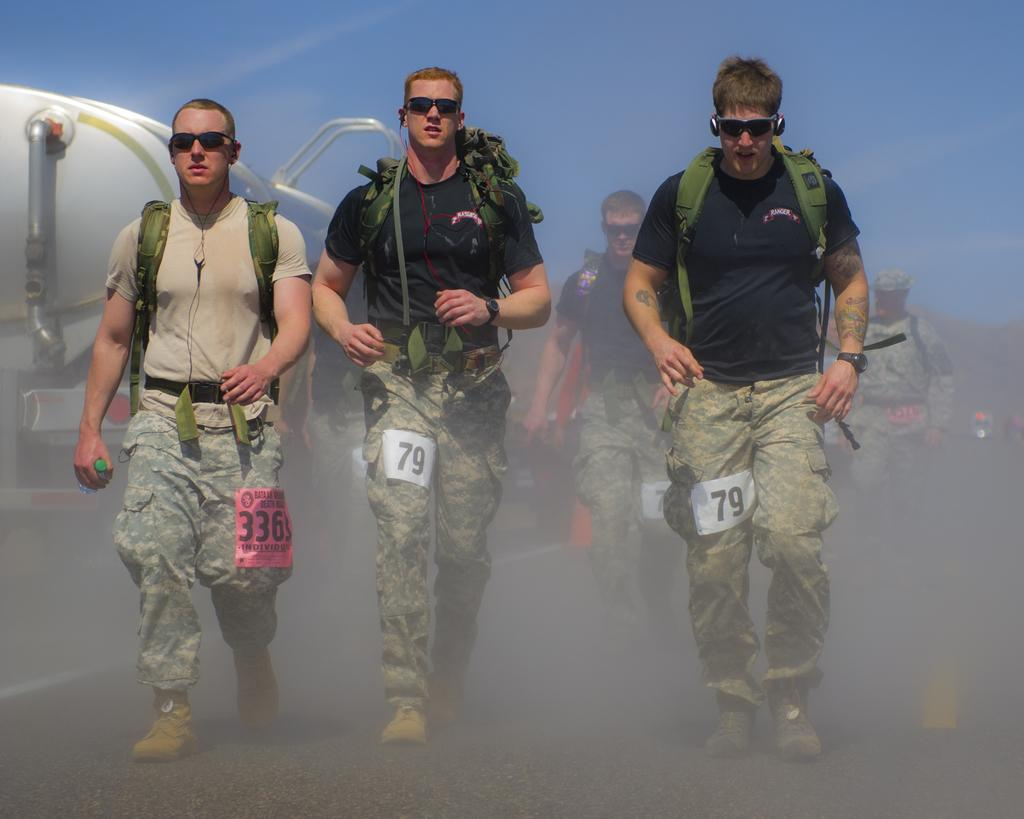What is happening in the image involving the group of people? The people in the image are walking. Can you describe the clothing of one person in the group? One person in front is wearing a black shirt. What can be seen in the background of the image? There is a vehicle in the background of the image. How would you describe the color of the sky in the image? The sky is blue and white in color. What type of pump can be seen in the image? There is no pump present in the image. Are there any dinosaurs visible in the image? No, there are no dinosaurs in the image. Can you see a chessboard or chess pieces in the image? No, there is no chessboard or chess pieces in the image. 